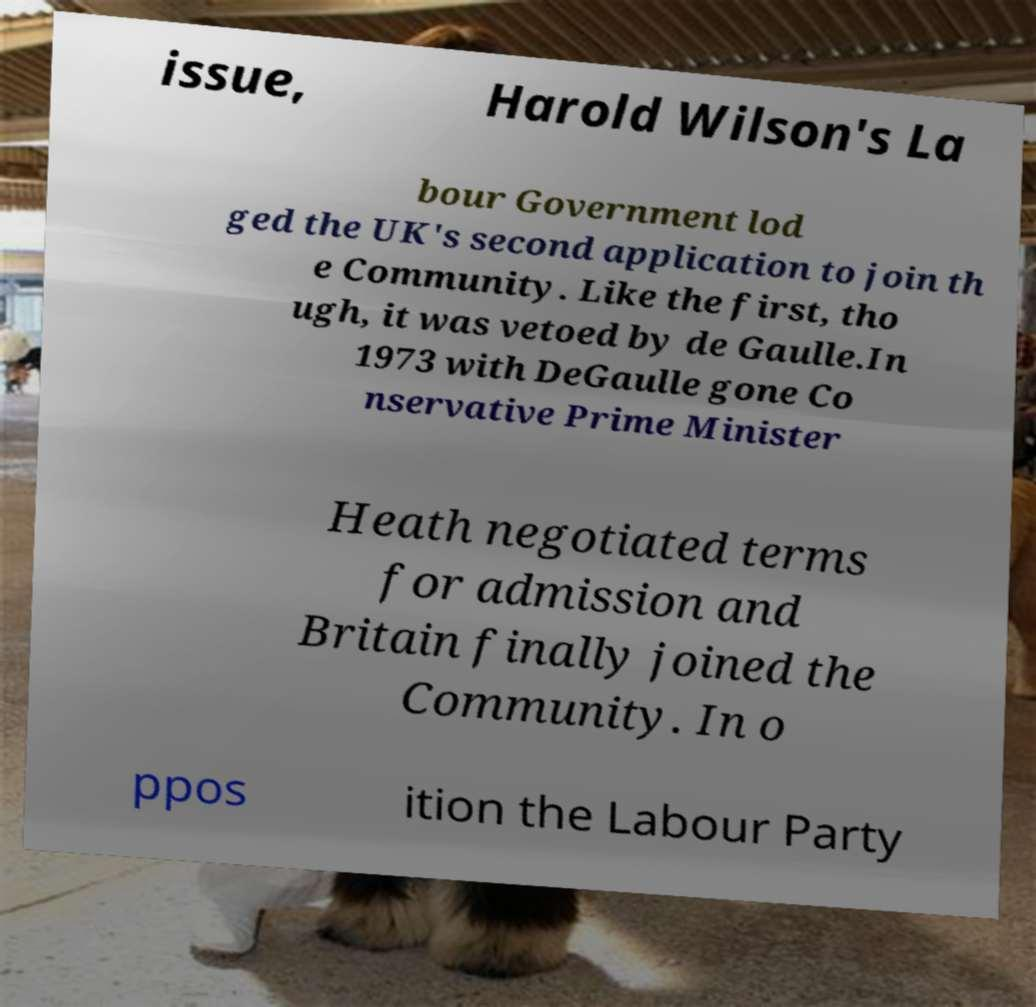For documentation purposes, I need the text within this image transcribed. Could you provide that? issue, Harold Wilson's La bour Government lod ged the UK's second application to join th e Community. Like the first, tho ugh, it was vetoed by de Gaulle.In 1973 with DeGaulle gone Co nservative Prime Minister Heath negotiated terms for admission and Britain finally joined the Community. In o ppos ition the Labour Party 